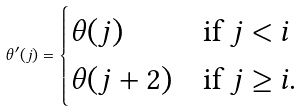Convert formula to latex. <formula><loc_0><loc_0><loc_500><loc_500>\theta ^ { \prime } ( j ) = \begin{cases} \theta ( j ) & \text {if } j < i \\ \theta ( j + 2 ) & \text {if } j \geq i . \end{cases}</formula> 